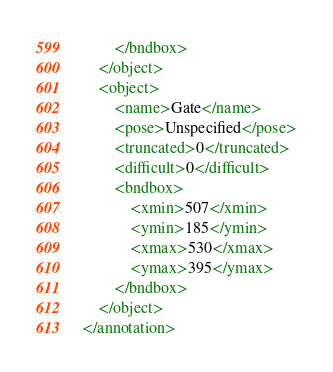Convert code to text. <code><loc_0><loc_0><loc_500><loc_500><_XML_>		</bndbox>
	</object>
	<object>
		<name>Gate</name>
		<pose>Unspecified</pose>
		<truncated>0</truncated>
		<difficult>0</difficult>
		<bndbox>
			<xmin>507</xmin>
			<ymin>185</ymin>
			<xmax>530</xmax>
			<ymax>395</ymax>
		</bndbox>
	</object>
</annotation>
</code> 